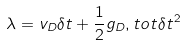<formula> <loc_0><loc_0><loc_500><loc_500>\lambda = v _ { D } \delta t + \frac { 1 } { 2 } g _ { D } , t o t \delta t ^ { 2 }</formula> 